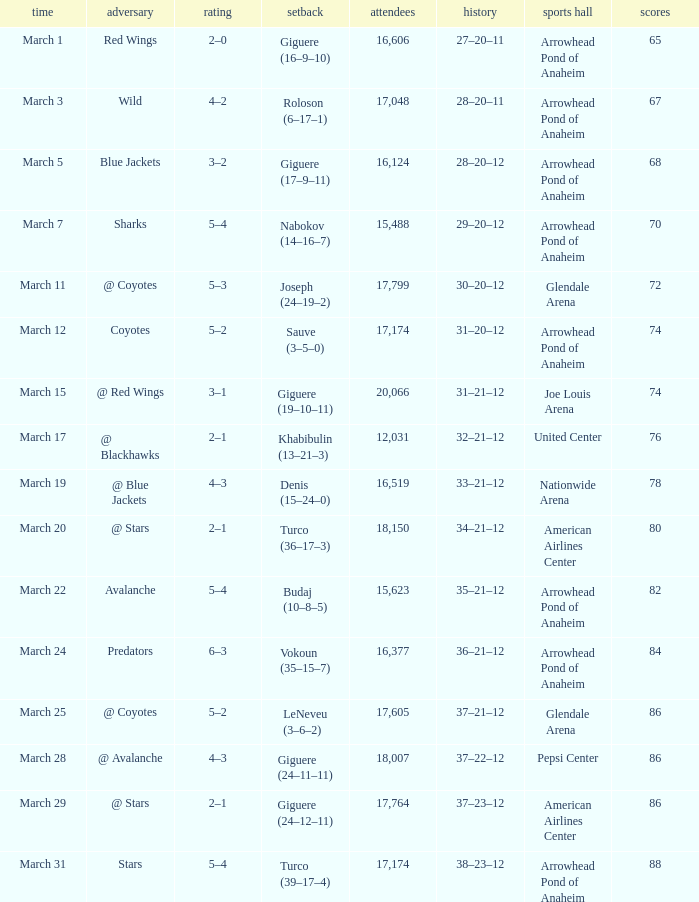What is the Attendance at Joe Louis Arena? 20066.0. 